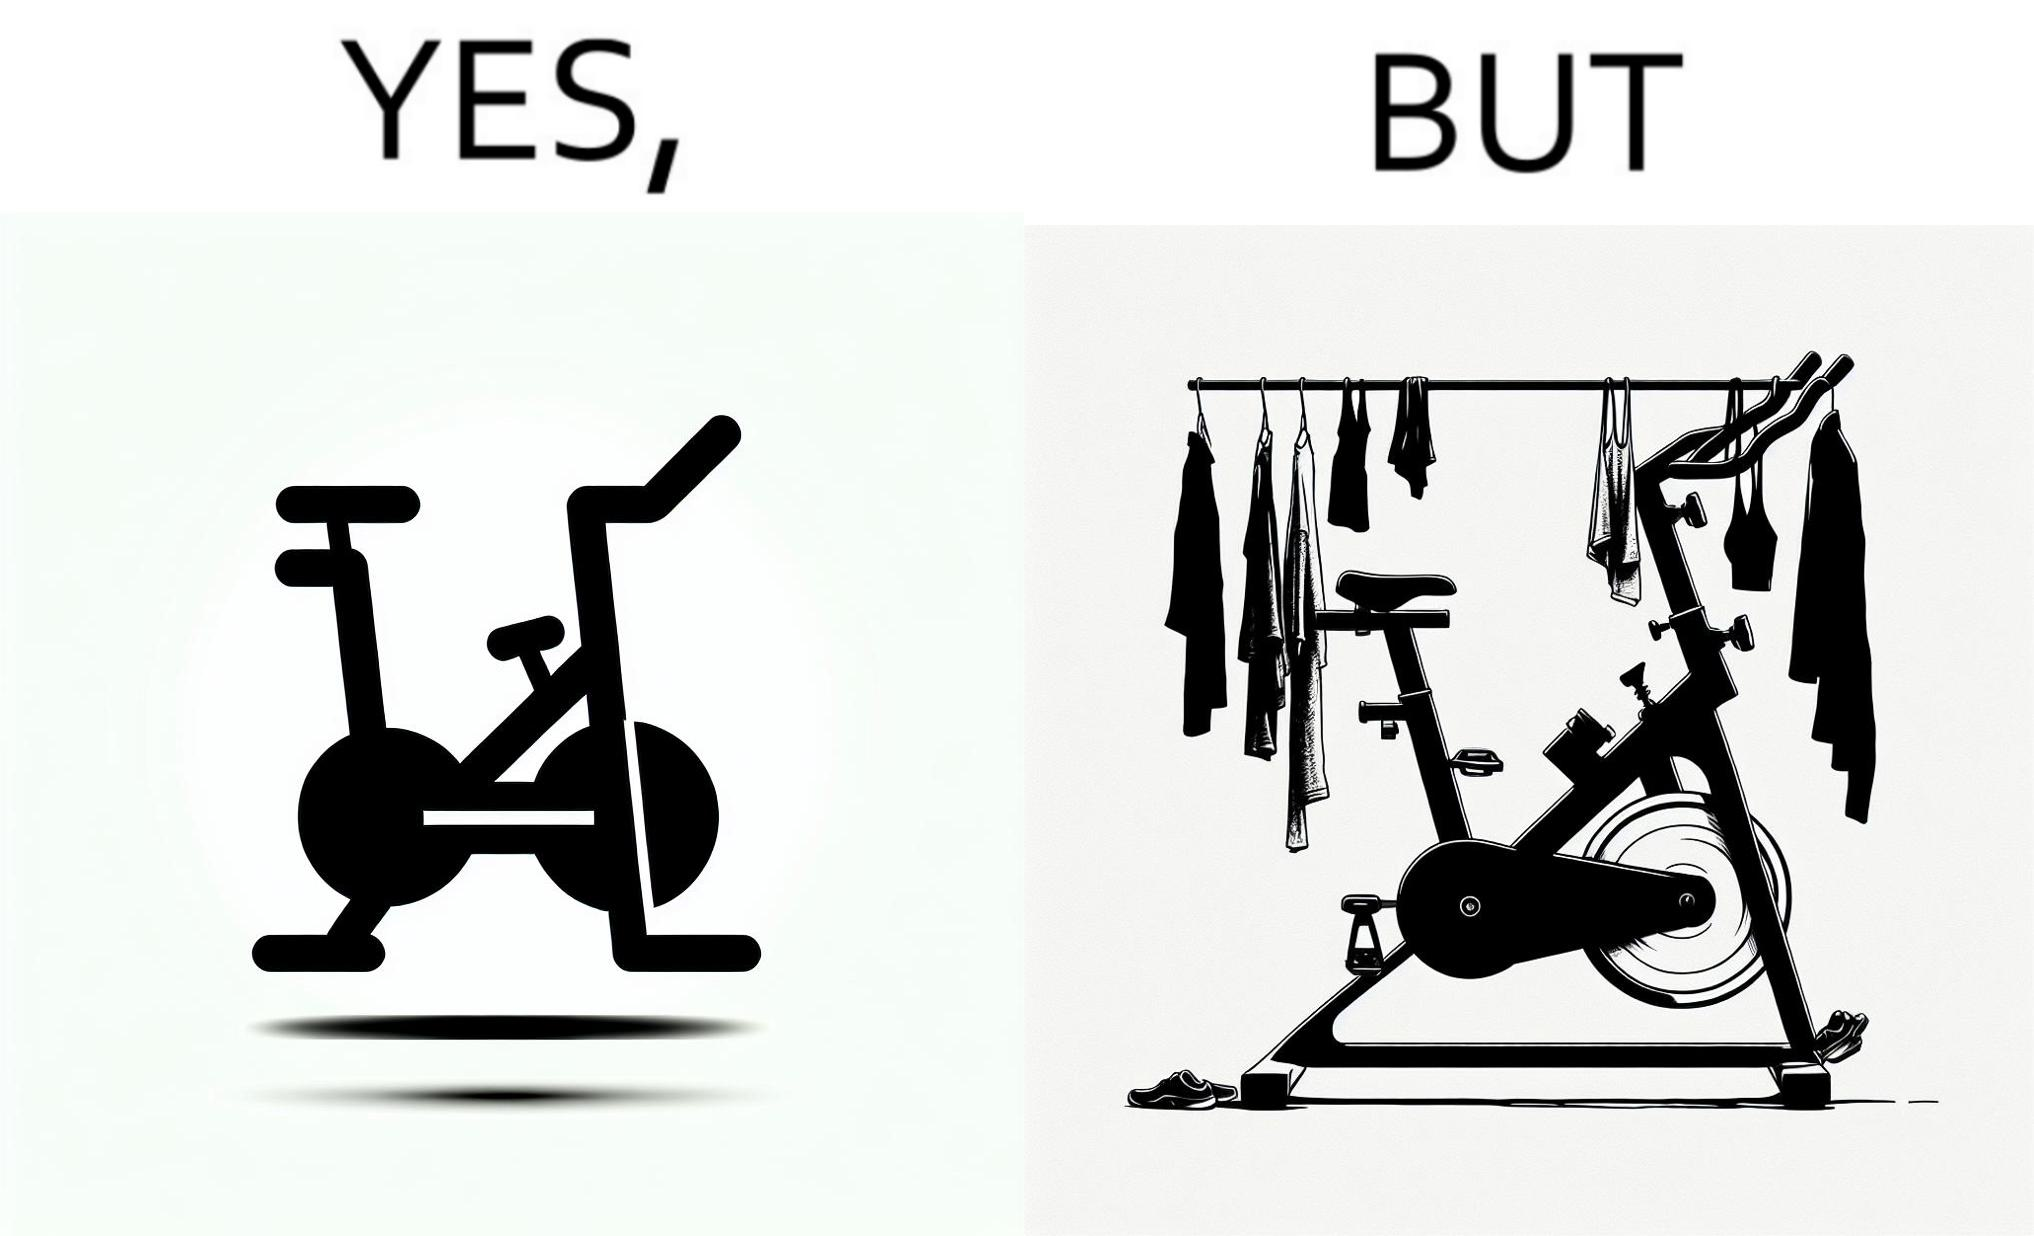Provide a description of this image. The images are funny since they show an exercise bike has been bought but is not being used for its purpose, that is, exercising. It is rather being used to hang clothes, bags and other items 